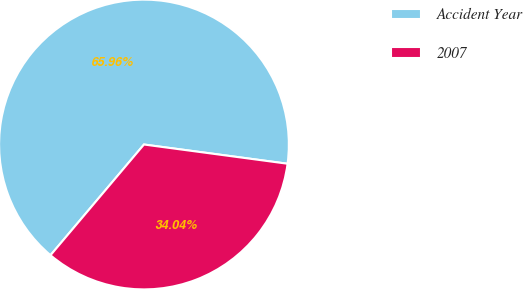Convert chart to OTSL. <chart><loc_0><loc_0><loc_500><loc_500><pie_chart><fcel>Accident Year<fcel>2007<nl><fcel>65.96%<fcel>34.04%<nl></chart> 